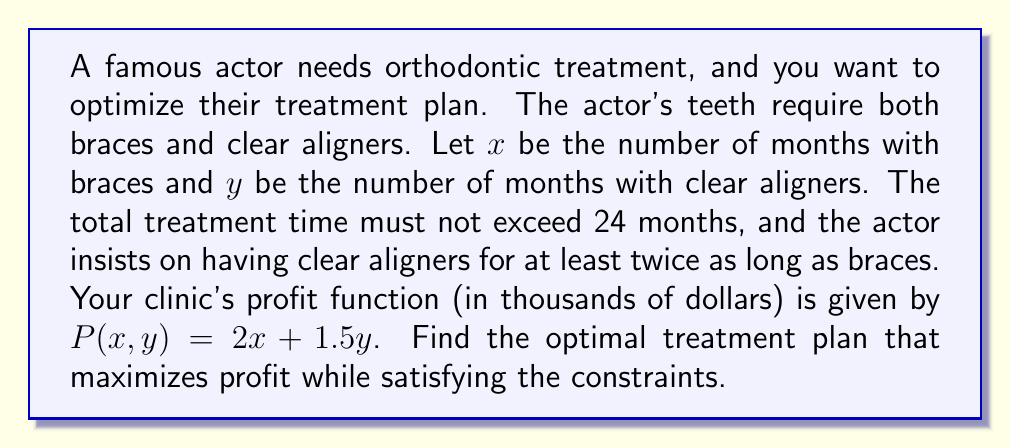Solve this math problem. Let's approach this step-by-step:

1) First, let's identify our constraints:
   a) Total treatment time: $x + y \leq 24$
   b) Clear aligner time requirement: $y \geq 2x$
   c) Non-negativity: $x \geq 0$, $y \geq 0$

2) Our objective function (profit) is:
   $P = 2x + 1.5y$

3) To maximize profit, we need to find the point where these constraints intersect at the highest possible value of P.

4) Let's graph our constraints:
   $x + y = 24$ (equality for maximum time)
   $y = 2x$

5) These lines intersect at the point where:
   $2x + x = 24$
   $3x = 24$
   $x = 8$

6) Substituting back:
   $y = 2(8) = 16$

7) Let's verify this satisfies all constraints:
   $8 + 16 = 24$ (meets maximum time)
   $16 \geq 2(8)$ (meets clear aligner requirement)
   Both $x$ and $y$ are non-negative

8) Calculate the profit:
   $P = 2(8) + 1.5(16) = 16 + 24 = 40$

Therefore, the optimal treatment plan is 8 months of braces and 16 months of clear aligners, yielding a profit of $40,000.
Answer: 8 months braces, 16 months clear aligners 